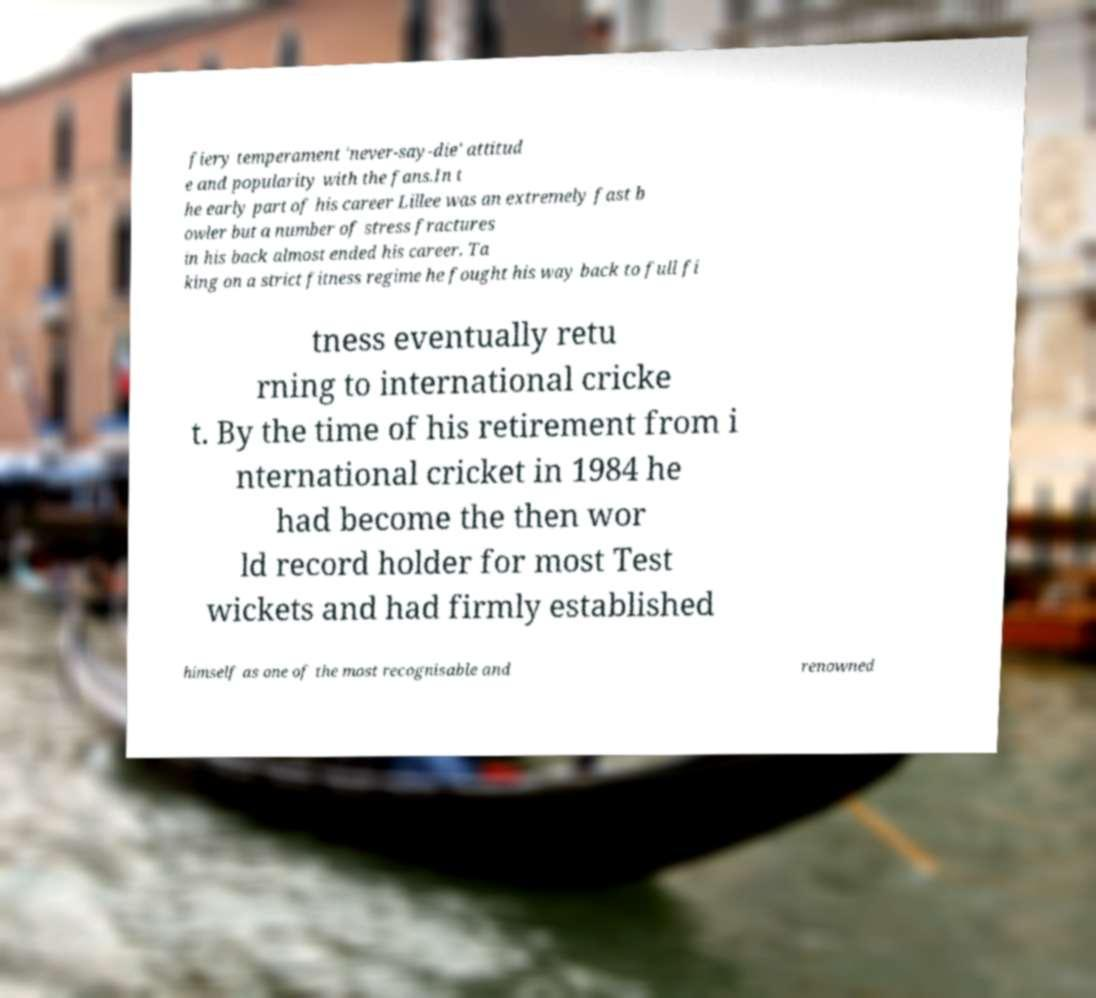Could you assist in decoding the text presented in this image and type it out clearly? fiery temperament 'never-say-die' attitud e and popularity with the fans.In t he early part of his career Lillee was an extremely fast b owler but a number of stress fractures in his back almost ended his career. Ta king on a strict fitness regime he fought his way back to full fi tness eventually retu rning to international cricke t. By the time of his retirement from i nternational cricket in 1984 he had become the then wor ld record holder for most Test wickets and had firmly established himself as one of the most recognisable and renowned 